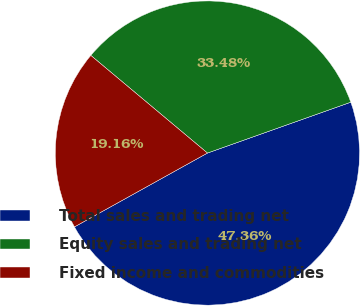Convert chart to OTSL. <chart><loc_0><loc_0><loc_500><loc_500><pie_chart><fcel>Total sales and trading net<fcel>Equity sales and trading net<fcel>Fixed income and commodities<nl><fcel>47.36%<fcel>33.48%<fcel>19.16%<nl></chart> 